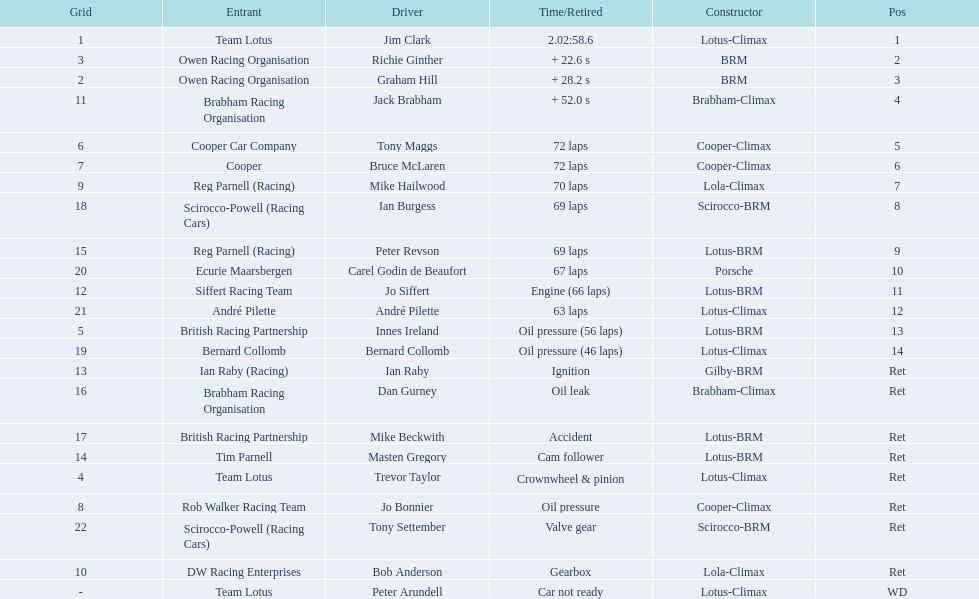Who are all the drivers? Jim Clark, Richie Ginther, Graham Hill, Jack Brabham, Tony Maggs, Bruce McLaren, Mike Hailwood, Ian Burgess, Peter Revson, Carel Godin de Beaufort, Jo Siffert, André Pilette, Innes Ireland, Bernard Collomb, Ian Raby, Dan Gurney, Mike Beckwith, Masten Gregory, Trevor Taylor, Jo Bonnier, Tony Settember, Bob Anderson, Peter Arundell. What were their positions? 1, 2, 3, 4, 5, 6, 7, 8, 9, 10, 11, 12, 13, 14, Ret, Ret, Ret, Ret, Ret, Ret, Ret, Ret, WD. What are all the constructor names? Lotus-Climax, BRM, BRM, Brabham-Climax, Cooper-Climax, Cooper-Climax, Lola-Climax, Scirocco-BRM, Lotus-BRM, Porsche, Lotus-BRM, Lotus-Climax, Lotus-BRM, Lotus-Climax, Gilby-BRM, Brabham-Climax, Lotus-BRM, Lotus-BRM, Lotus-Climax, Cooper-Climax, Scirocco-BRM, Lola-Climax, Lotus-Climax. And which drivers drove a cooper-climax? Tony Maggs, Bruce McLaren. Between those tow, who was positioned higher? Tony Maggs. 